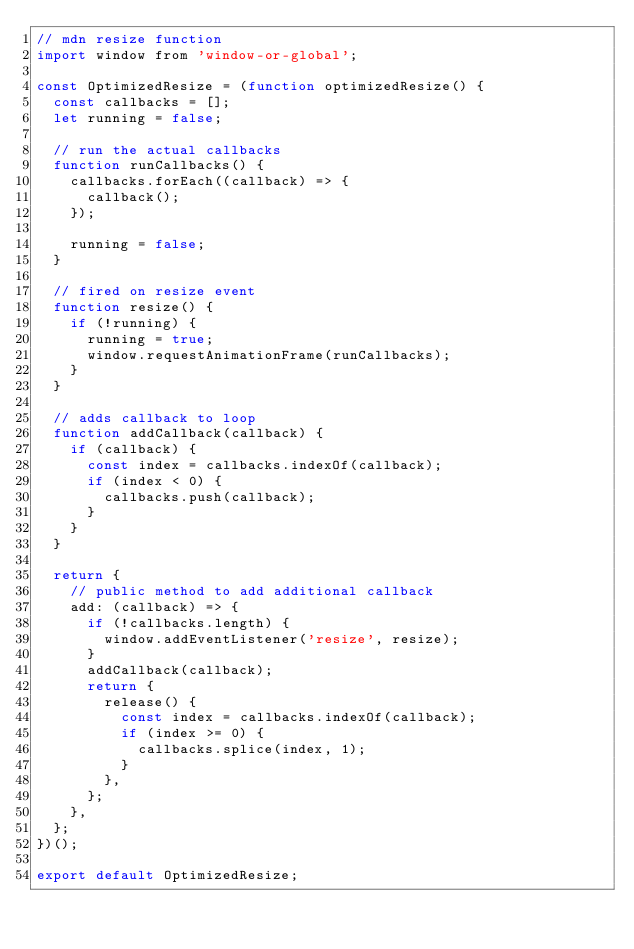<code> <loc_0><loc_0><loc_500><loc_500><_JavaScript_>// mdn resize function
import window from 'window-or-global';

const OptimizedResize = (function optimizedResize() {
  const callbacks = [];
  let running = false;

  // run the actual callbacks
  function runCallbacks() {
    callbacks.forEach((callback) => {
      callback();
    });

    running = false;
  }

  // fired on resize event
  function resize() {
    if (!running) {
      running = true;
      window.requestAnimationFrame(runCallbacks);
    }
  }

  // adds callback to loop
  function addCallback(callback) {
    if (callback) {
      const index = callbacks.indexOf(callback);
      if (index < 0) {
        callbacks.push(callback);
      }
    }
  }

  return {
    // public method to add additional callback
    add: (callback) => {
      if (!callbacks.length) {
        window.addEventListener('resize', resize);
      }
      addCallback(callback);
      return {
        release() {
          const index = callbacks.indexOf(callback);
          if (index >= 0) {
            callbacks.splice(index, 1);
          }
        },
      };
    },
  };
})();

export default OptimizedResize;
</code> 